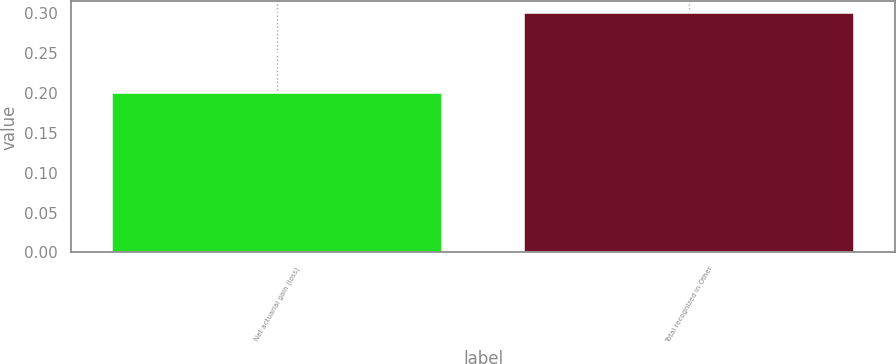Convert chart. <chart><loc_0><loc_0><loc_500><loc_500><bar_chart><fcel>Net actuarial gain (loss)<fcel>Total recognized in Other<nl><fcel>0.2<fcel>0.3<nl></chart> 